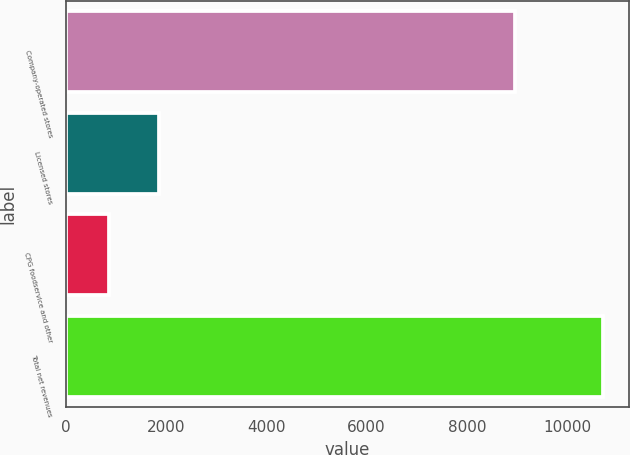Convert chart to OTSL. <chart><loc_0><loc_0><loc_500><loc_500><bar_chart><fcel>Company-operated stores<fcel>Licensed stores<fcel>CPG foodservice and other<fcel>Total net revenues<nl><fcel>8963.5<fcel>1852.57<fcel>868.7<fcel>10707.4<nl></chart> 